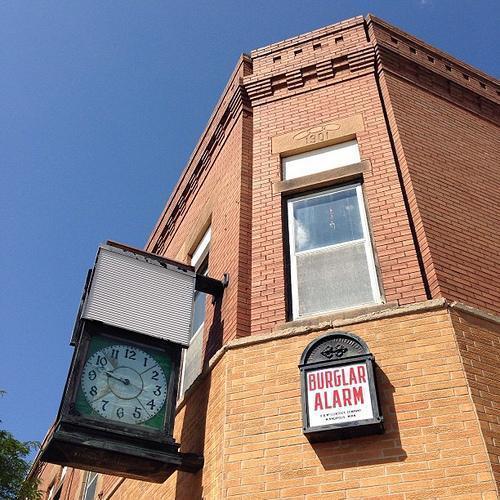How many clocks are there?
Give a very brief answer. 1. 